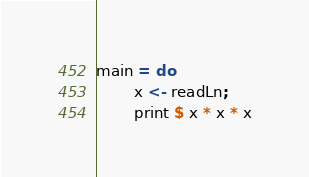Convert code to text. <code><loc_0><loc_0><loc_500><loc_500><_Haskell_>main = do
        x <- readLn;
        print $ x * x * x</code> 